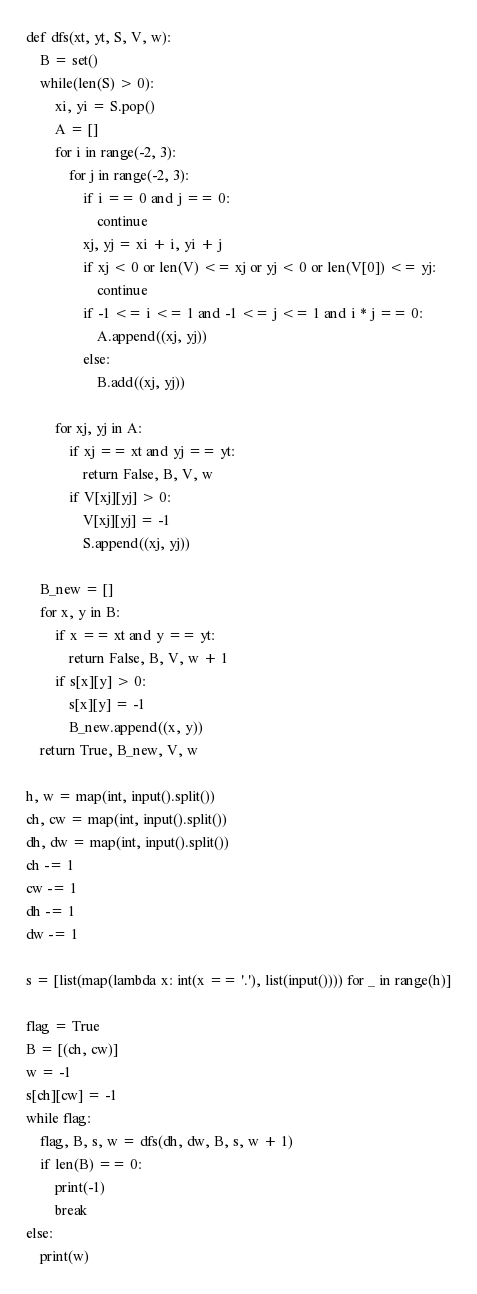Convert code to text. <code><loc_0><loc_0><loc_500><loc_500><_Python_>def dfs(xt, yt, S, V, w):
    B = set()
    while(len(S) > 0):
        xi, yi = S.pop()
        A = []
        for i in range(-2, 3):
            for j in range(-2, 3):
                if i == 0 and j == 0:
                    continue
                xj, yj = xi + i, yi + j
                if xj < 0 or len(V) <= xj or yj < 0 or len(V[0]) <= yj:
                    continue
                if -1 <= i <= 1 and -1 <= j <= 1 and i * j == 0:
                    A.append((xj, yj))
                else:
                    B.add((xj, yj))

        for xj, yj in A:
            if xj == xt and yj == yt:
                return False, B, V, w
            if V[xj][yj] > 0:
                V[xj][yj] = -1
                S.append((xj, yj))

    B_new = []
    for x, y in B:
        if x == xt and y == yt:
            return False, B, V, w + 1
        if s[x][y] > 0:
            s[x][y] = -1
            B_new.append((x, y))
    return True, B_new, V, w

h, w = map(int, input().split())
ch, cw = map(int, input().split())
dh, dw = map(int, input().split())
ch -= 1
cw -= 1
dh -= 1
dw -= 1

s = [list(map(lambda x: int(x == '.'), list(input()))) for _ in range(h)]

flag = True
B = [(ch, cw)]
w = -1
s[ch][cw] = -1
while flag:
    flag, B, s, w = dfs(dh, dw, B, s, w + 1)
    if len(B) == 0:
        print(-1)
        break
else:
    print(w)
</code> 